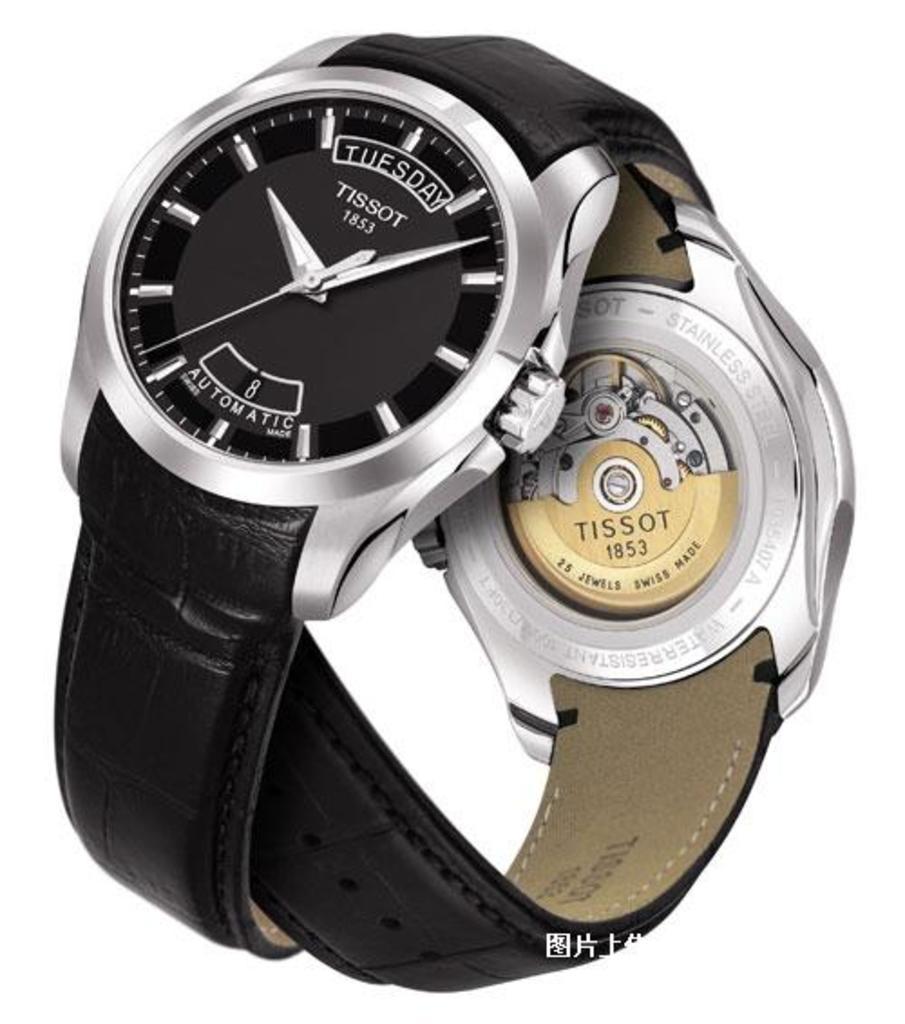What brand of watch is this?
Your response must be concise. Tissot. Is the watch automatic?
Your response must be concise. Yes. 